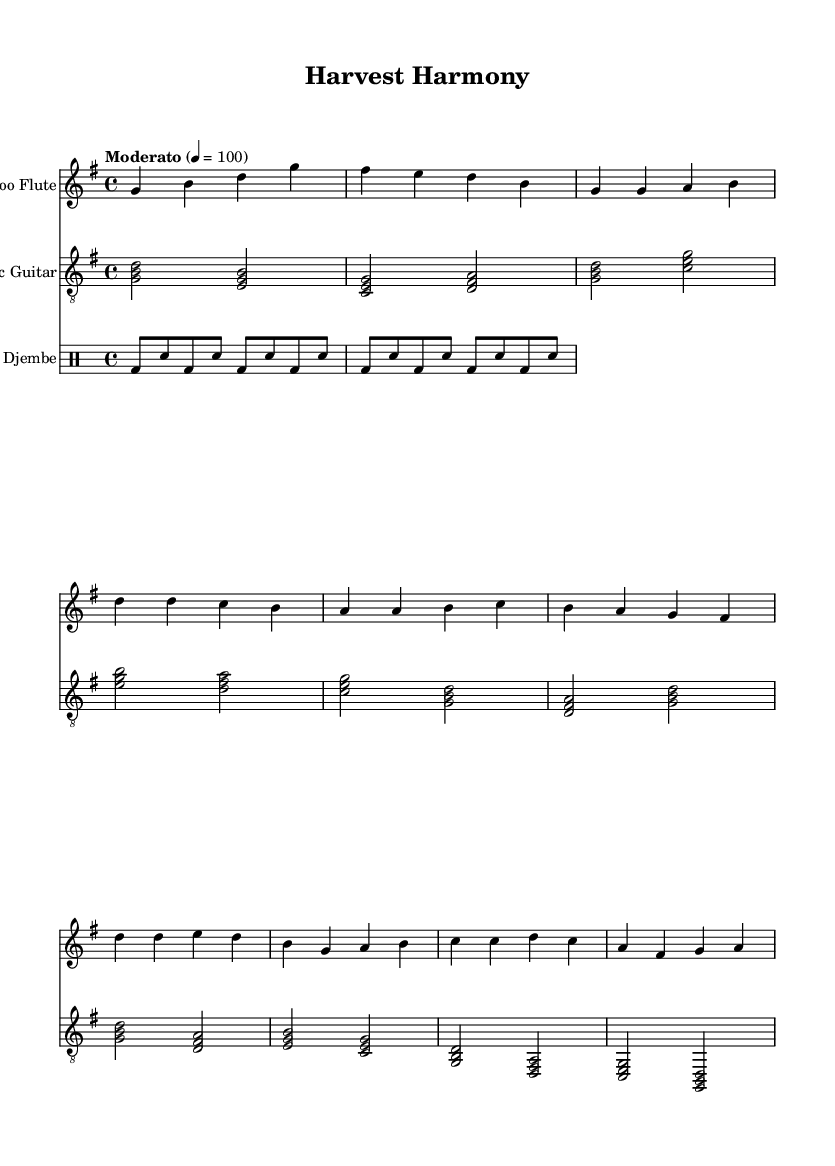What is the key signature of this music? The key signature is G major, which has one sharp (F#). This can be determined by looking at the key signature indicated in the staff at the beginning of the music.
Answer: G major What is the time signature of this piece? The time signature is 4/4, which is found at the beginning of the score. This indicates that there are four beats in each measure and the quarter note gets one beat.
Answer: 4/4 What is the tempo marking? The tempo marking is "Moderato" with a quarter note = 100. This information is located within the tempo statement at the beginning, indicating a moderate speed of 100 beats per minute.
Answer: Moderato, 100 How many measures are there in the chorus? The chorus consists of four measures, which can be counted from the notation provided in the score. Each measure is separated by a vertical line, making it easy to tally the total.
Answer: 4 Which instrument plays the rhythm pattern? The instrument that plays the rhythm pattern is the Djembe, as indicated by the separate staff labeled "Djembe" in the score. The notation follows drumming conventions specific to that instrument.
Answer: Djembe What melodic line begins with the note G? The Bamboo Flute's melodic line begins with the note G, which appears at the start of its respective staff in the score. This serves as the introduction of the piece, establishing the thematic material.
Answer: Bamboo Flute Which instrument takes on a harmonic role accompanying the melody? The Acoustic Guitar takes on a harmonic role, accompanying the melody by playing chords that support the thematic material found in the Bamboo Flute's line. This can be observed through the chords written on its staff.
Answer: Acoustic Guitar 